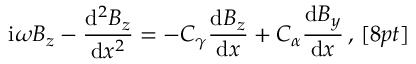Convert formula to latex. <formula><loc_0><loc_0><loc_500><loc_500>i \omega B _ { z } - \frac { d ^ { 2 } B _ { z } } { d x ^ { 2 } } = - C _ { \gamma } \frac { d B _ { z } } { d x } + C _ { \alpha } \frac { d B _ { y } } { d x } \, , \, [ 8 p t ]</formula> 